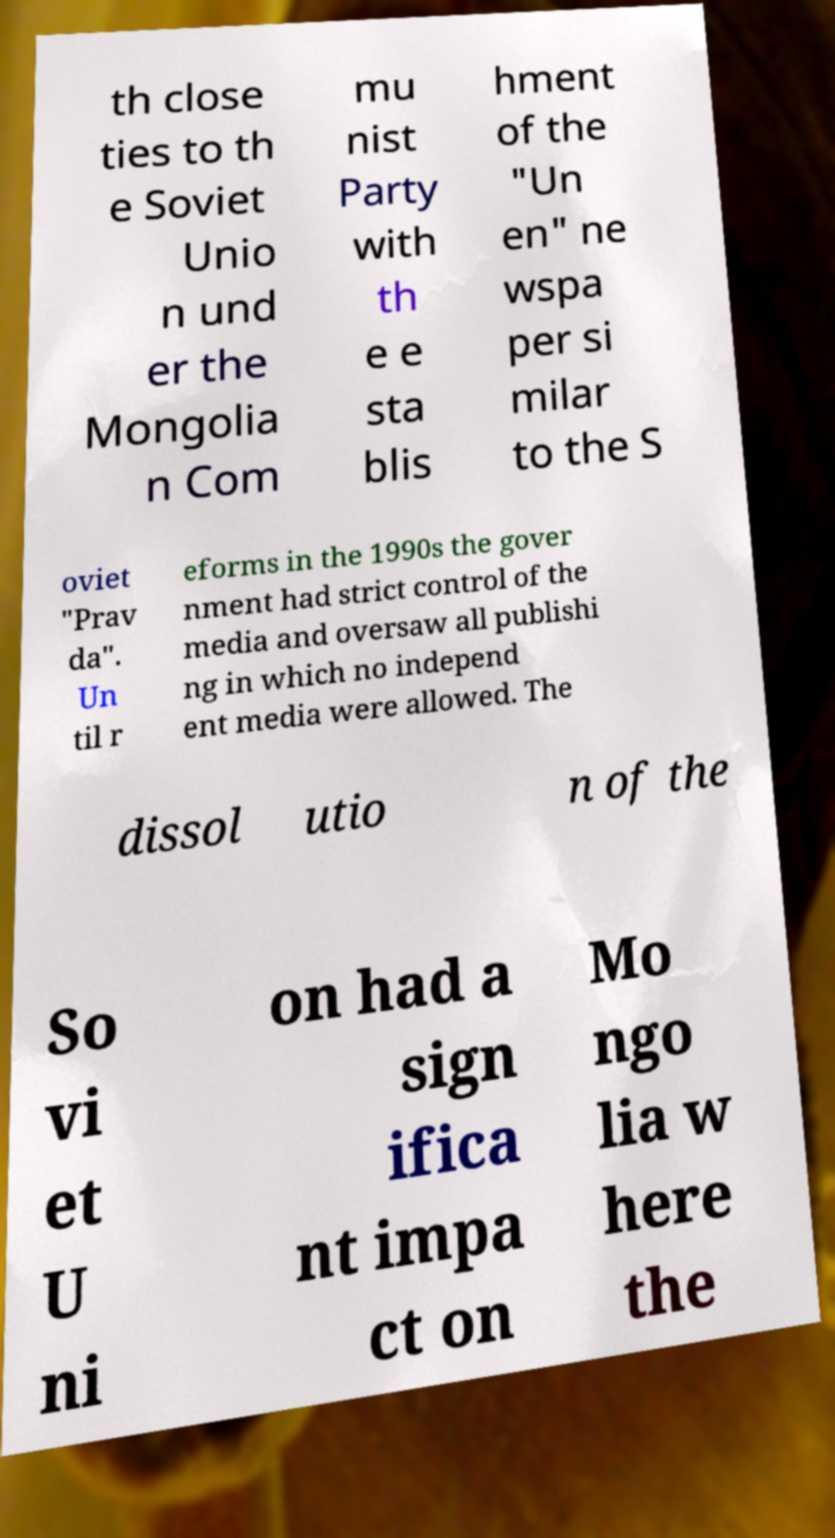Could you assist in decoding the text presented in this image and type it out clearly? th close ties to th e Soviet Unio n und er the Mongolia n Com mu nist Party with th e e sta blis hment of the "Un en" ne wspa per si milar to the S oviet "Prav da". Un til r eforms in the 1990s the gover nment had strict control of the media and oversaw all publishi ng in which no independ ent media were allowed. The dissol utio n of the So vi et U ni on had a sign ifica nt impa ct on Mo ngo lia w here the 